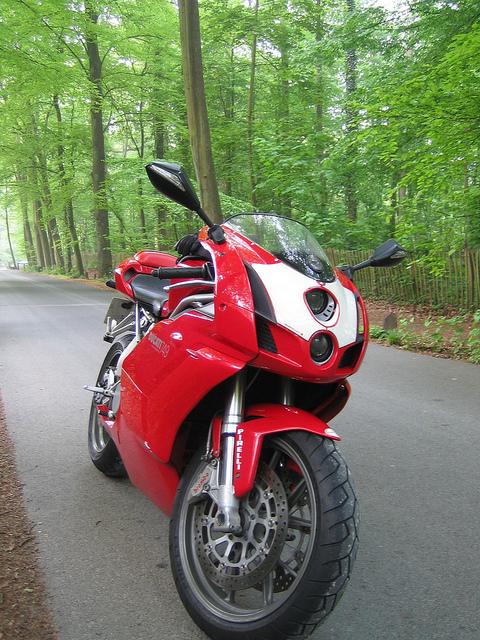Would you see a motorcycle like this being used by the main characters of 'Sons of Anarchy?'?
Keep it brief. No. Where is the motorcycle parked?
Write a very short answer. Street. Is the brand and model of the bike visible in the image?
Quick response, please. No. What color is the bike?
Write a very short answer. Red. 